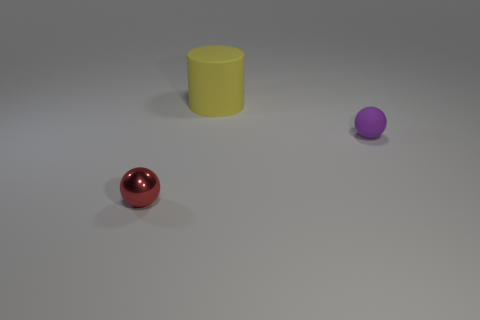Add 2 tiny red things. How many objects exist? 5 Subtract all cylinders. How many objects are left? 2 Add 3 big matte cylinders. How many big matte cylinders exist? 4 Subtract 0 red cylinders. How many objects are left? 3 Subtract all red blocks. Subtract all red objects. How many objects are left? 2 Add 3 matte things. How many matte things are left? 5 